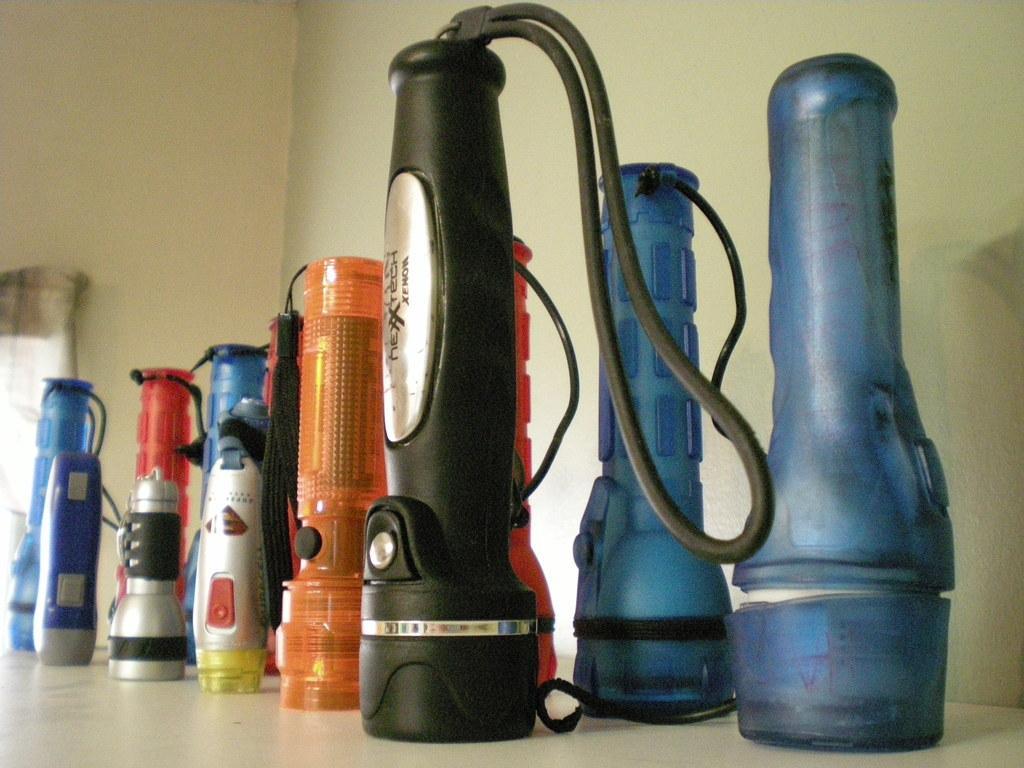In one or two sentences, can you explain what this image depicts? In this image I can see some torch lights which are in different colors, are placed on the floor. In the background, I can see the wall. 